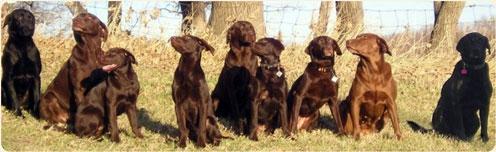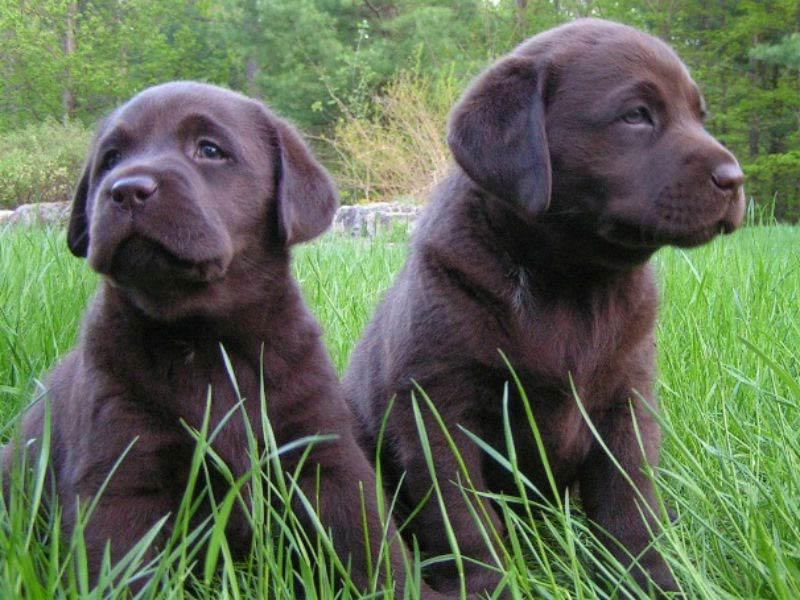The first image is the image on the left, the second image is the image on the right. Given the left and right images, does the statement "An image includes eight nearly white dogs of the same breed." hold true? Answer yes or no. No. The first image is the image on the left, the second image is the image on the right. For the images shown, is this caption "The right image contains exactly three dogs." true? Answer yes or no. No. 